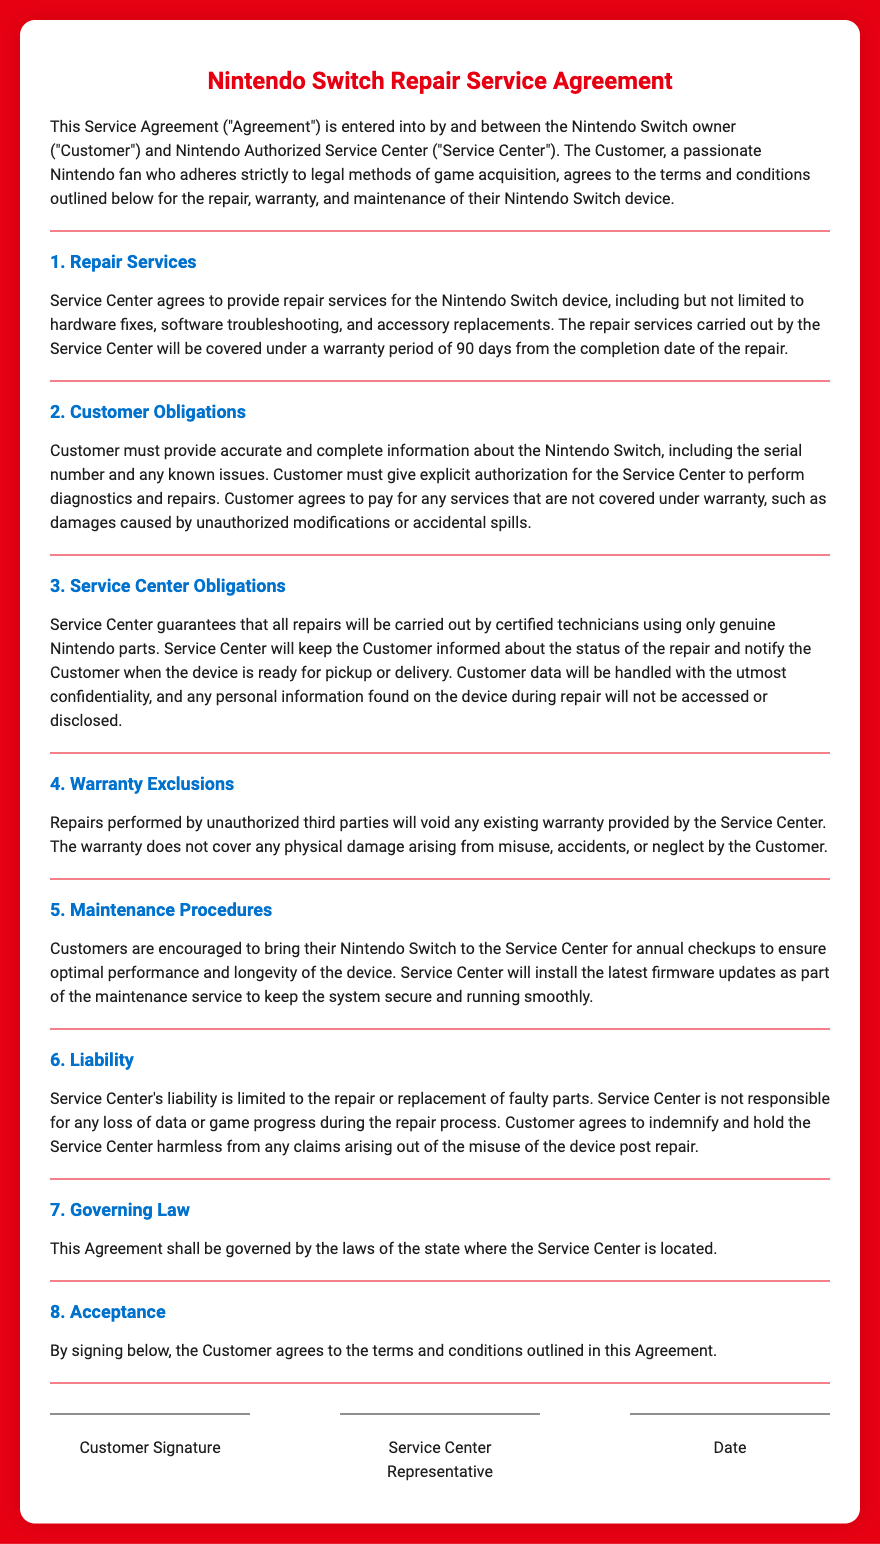What is the warranty period for repairs? The warranty period for repairs is stated in the document as 90 days from the completion date of the repair.
Answer: 90 days What must the Customer provide for repair? The document states that the Customer must provide accurate and complete information about the Nintendo Switch, including the serial number and any known issues.
Answer: Serial number and known issues Who performs the repairs? The document specifies that all repairs will be carried out by certified technicians.
Answer: Certified technicians What happens if unauthorized repairs are performed? According to the document, repairs performed by unauthorized third parties will void any existing warranty provided by the Service Center.
Answer: Voids warranty How often is the Customer encouraged to visit for maintenance? The document encourages Customers to bring their Nintendo Switch to the Service Center for annual checkups.
Answer: Annual checkups What is the liability of the Service Center? The document indicates that the Service Center's liability is limited to the repair or replacement of faulty parts.
Answer: Repair or replacement of faulty parts What type of damages does the warranty not cover? The document states that the warranty does not cover physical damage arising from misuse, accidents, or neglect by the Customer.
Answer: Misuse, accidents, or neglect What type of updates will be installed during maintenance? The document mentions that the latest firmware updates will be installed as part of the maintenance service.
Answer: Latest firmware updates 